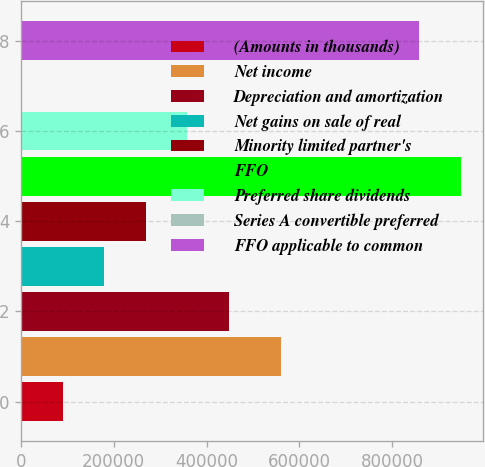<chart> <loc_0><loc_0><loc_500><loc_500><bar_chart><fcel>(Amounts in thousands)<fcel>Net income<fcel>Depreciation and amortization<fcel>Net gains on sale of real<fcel>Minority limited partner's<fcel>FFO<fcel>Preferred share dividends<fcel>Series A convertible preferred<fcel>FFO applicable to common<nl><fcel>90139.6<fcel>560140<fcel>448174<fcel>179648<fcel>269157<fcel>948202<fcel>358665<fcel>631<fcel>858693<nl></chart> 